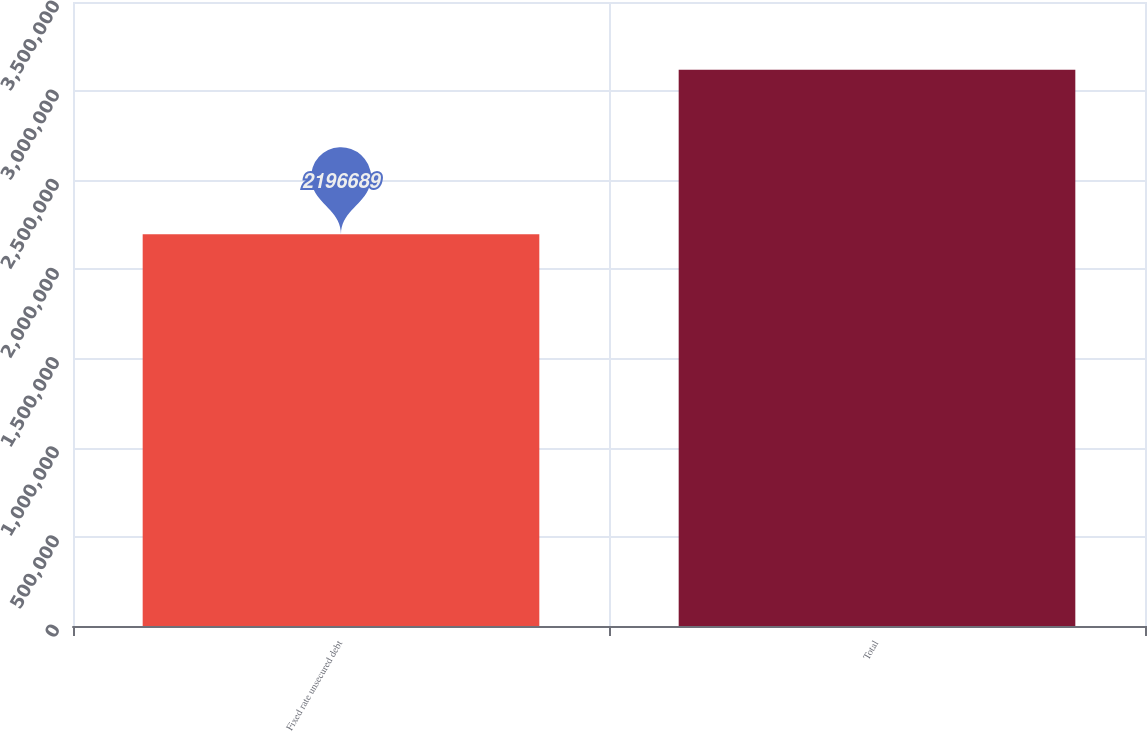Convert chart to OTSL. <chart><loc_0><loc_0><loc_500><loc_500><bar_chart><fcel>Fixed rate unsecured debt<fcel>Total<nl><fcel>2.19669e+06<fcel>3.12011e+06<nl></chart> 